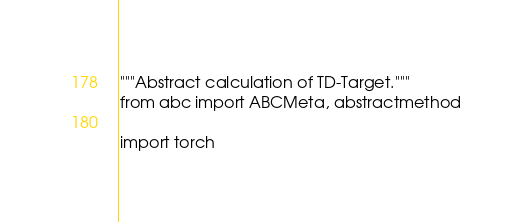<code> <loc_0><loc_0><loc_500><loc_500><_Python_>"""Abstract calculation of TD-Target."""
from abc import ABCMeta, abstractmethod

import torch</code> 